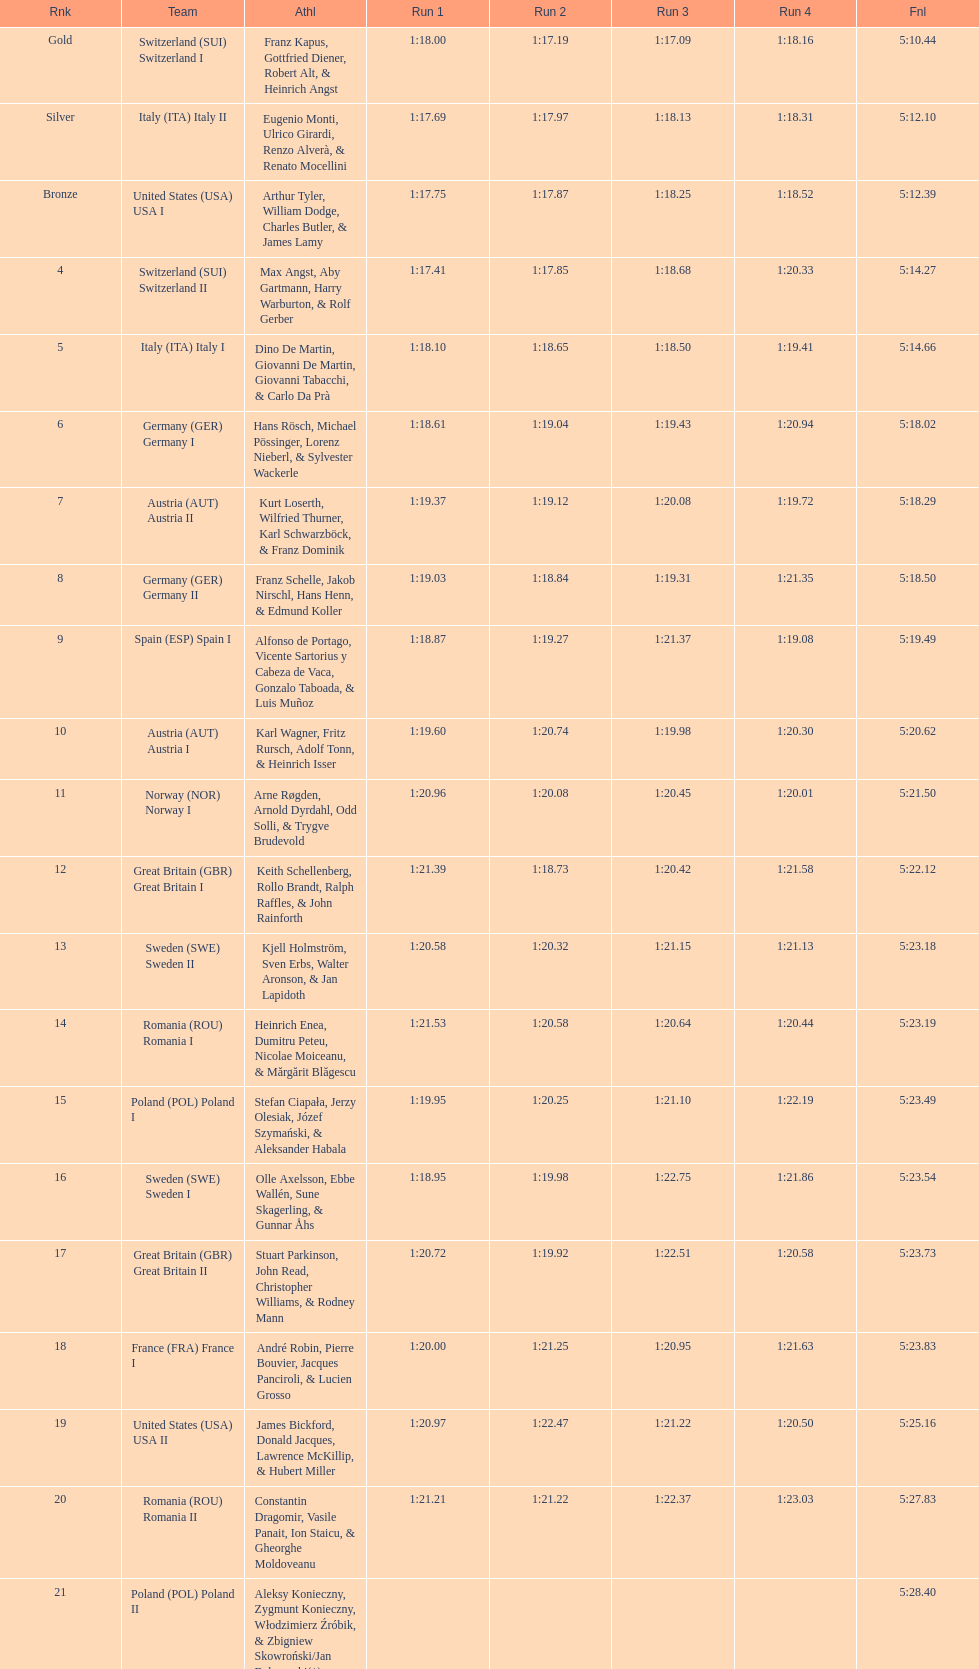Which team won the most runs? Switzerland. 